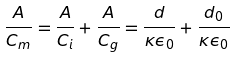Convert formula to latex. <formula><loc_0><loc_0><loc_500><loc_500>\frac { A } { C _ { m } } = \frac { A } { C _ { i } } + \frac { A } { C _ { g } } = \frac { d } { \kappa \epsilon _ { 0 } } + \frac { d _ { 0 } } { \kappa \epsilon _ { 0 } }</formula> 